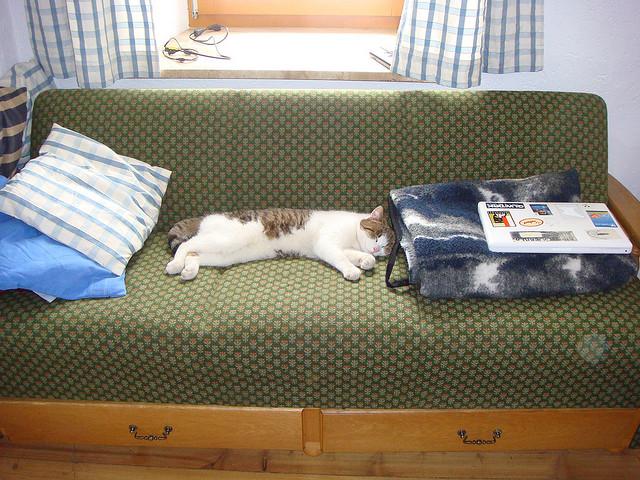Is the cat eating a salad?
Be succinct. No. Is the window open?
Be succinct. No. What pattern are the curtains?
Answer briefly. Plaid. What is the cat sleeping on?
Short answer required. Couch. 